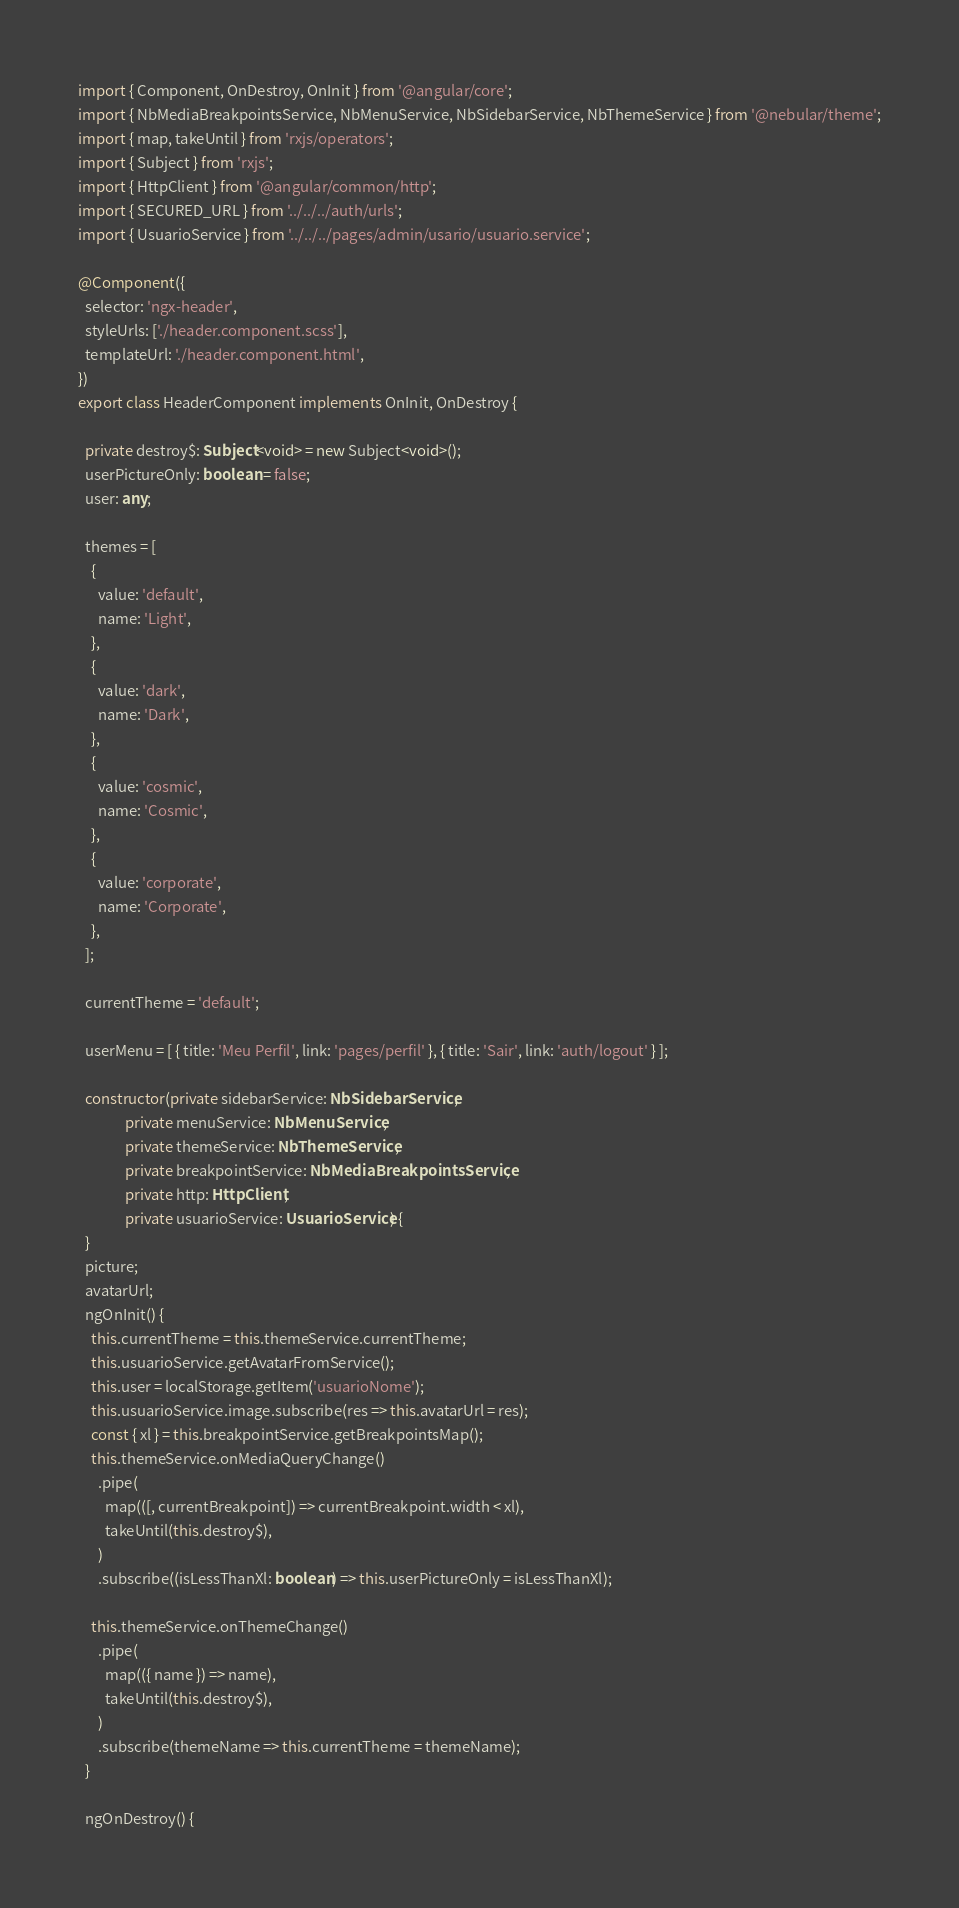Convert code to text. <code><loc_0><loc_0><loc_500><loc_500><_TypeScript_>import { Component, OnDestroy, OnInit } from '@angular/core';
import { NbMediaBreakpointsService, NbMenuService, NbSidebarService, NbThemeService } from '@nebular/theme';
import { map, takeUntil } from 'rxjs/operators';
import { Subject } from 'rxjs';
import { HttpClient } from '@angular/common/http';
import { SECURED_URL } from '../../../auth/urls';
import { UsuarioService } from '../../../pages/admin/usario/usuario.service';

@Component({
  selector: 'ngx-header',
  styleUrls: ['./header.component.scss'],
  templateUrl: './header.component.html',
})
export class HeaderComponent implements OnInit, OnDestroy {

  private destroy$: Subject<void> = new Subject<void>();
  userPictureOnly: boolean = false;
  user: any;

  themes = [
    {
      value: 'default',
      name: 'Light',
    },
    {
      value: 'dark',
      name: 'Dark',
    },
    {
      value: 'cosmic',
      name: 'Cosmic',
    },
    {
      value: 'corporate',
      name: 'Corporate',
    },
  ];

  currentTheme = 'default';

  userMenu = [ { title: 'Meu Perfil', link: 'pages/perfil' }, { title: 'Sair', link: 'auth/logout' } ];

  constructor(private sidebarService: NbSidebarService,
              private menuService: NbMenuService,
              private themeService: NbThemeService,
              private breakpointService: NbMediaBreakpointsService,
              private http: HttpClient,
              private usuarioService: UsuarioService) {
  }
  picture;
  avatarUrl;
  ngOnInit() {
    this.currentTheme = this.themeService.currentTheme;
    this.usuarioService.getAvatarFromService();
    this.user = localStorage.getItem('usuarioNome');
    this.usuarioService.image.subscribe(res => this.avatarUrl = res);
    const { xl } = this.breakpointService.getBreakpointsMap();
    this.themeService.onMediaQueryChange()
      .pipe(
        map(([, currentBreakpoint]) => currentBreakpoint.width < xl),
        takeUntil(this.destroy$),
      )
      .subscribe((isLessThanXl: boolean) => this.userPictureOnly = isLessThanXl);

    this.themeService.onThemeChange()
      .pipe(
        map(({ name }) => name),
        takeUntil(this.destroy$),
      )
      .subscribe(themeName => this.currentTheme = themeName);
  }

  ngOnDestroy() {</code> 